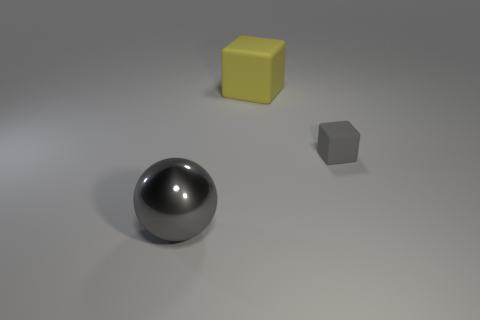Add 1 cyan shiny cylinders. How many objects exist? 4 Subtract all cubes. How many objects are left? 1 Add 2 red objects. How many red objects exist? 2 Subtract 0 red blocks. How many objects are left? 3 Subtract all tiny things. Subtract all large things. How many objects are left? 0 Add 2 yellow blocks. How many yellow blocks are left? 3 